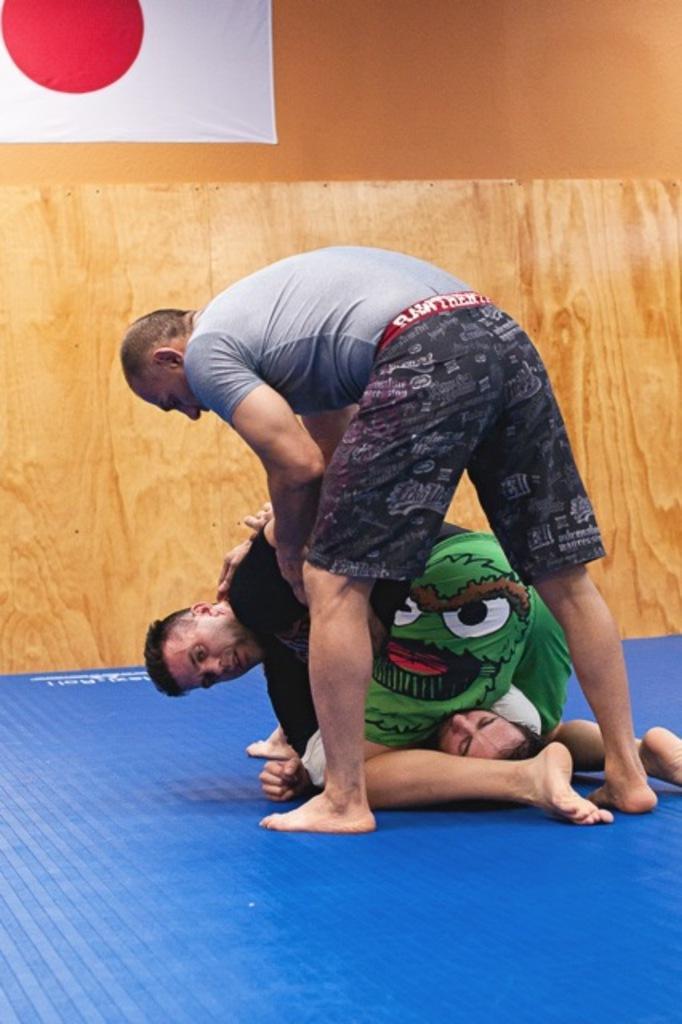In one or two sentences, can you explain what this image depicts? In this image in the center there are persons. In the background there is a wall and on the wall there is a banner hanging which is white and red in colour. 